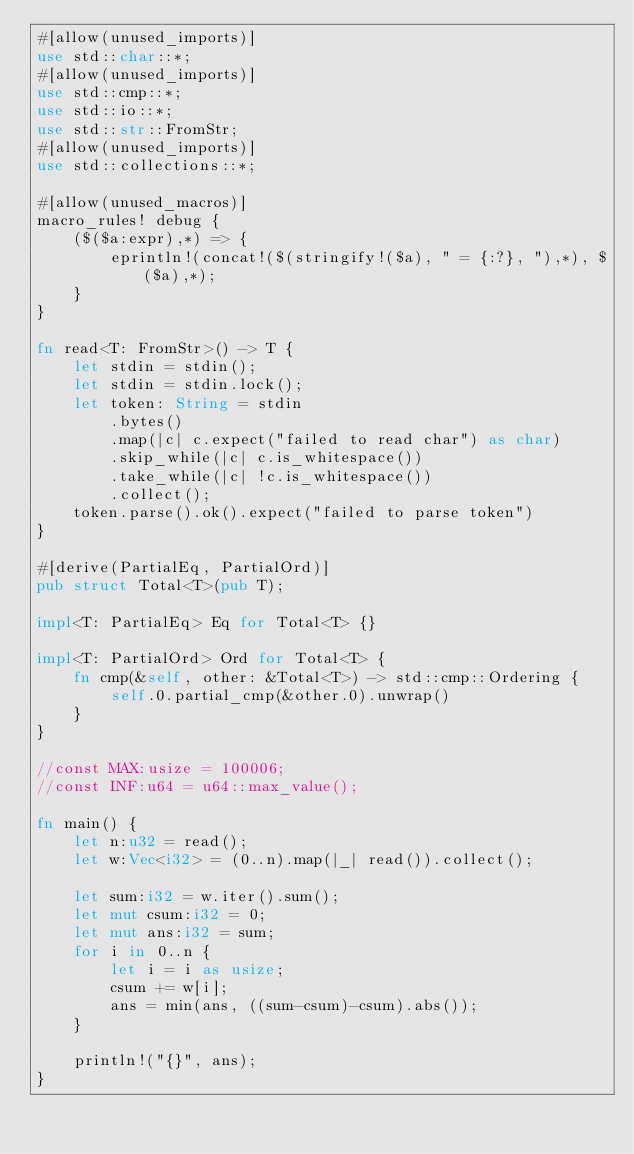Convert code to text. <code><loc_0><loc_0><loc_500><loc_500><_Rust_>#[allow(unused_imports)]
use std::char::*;
#[allow(unused_imports)]
use std::cmp::*;
use std::io::*;
use std::str::FromStr;
#[allow(unused_imports)]
use std::collections::*;

#[allow(unused_macros)]
macro_rules! debug {
    ($($a:expr),*) => {
        eprintln!(concat!($(stringify!($a), " = {:?}, "),*), $($a),*);
    }
}

fn read<T: FromStr>() -> T {
    let stdin = stdin();
    let stdin = stdin.lock();
    let token: String = stdin
        .bytes()
        .map(|c| c.expect("failed to read char") as char)
        .skip_while(|c| c.is_whitespace())
        .take_while(|c| !c.is_whitespace())
        .collect();
    token.parse().ok().expect("failed to parse token")
}

#[derive(PartialEq, PartialOrd)]
pub struct Total<T>(pub T);

impl<T: PartialEq> Eq for Total<T> {}

impl<T: PartialOrd> Ord for Total<T> {
    fn cmp(&self, other: &Total<T>) -> std::cmp::Ordering {
        self.0.partial_cmp(&other.0).unwrap()
    }
}

//const MAX:usize = 100006;
//const INF:u64 = u64::max_value();

fn main() {
    let n:u32 = read();
    let w:Vec<i32> = (0..n).map(|_| read()).collect();

    let sum:i32 = w.iter().sum();
    let mut csum:i32 = 0;
    let mut ans:i32 = sum;
    for i in 0..n {
        let i = i as usize;
        csum += w[i];
        ans = min(ans, ((sum-csum)-csum).abs());
    }

    println!("{}", ans);
}
</code> 